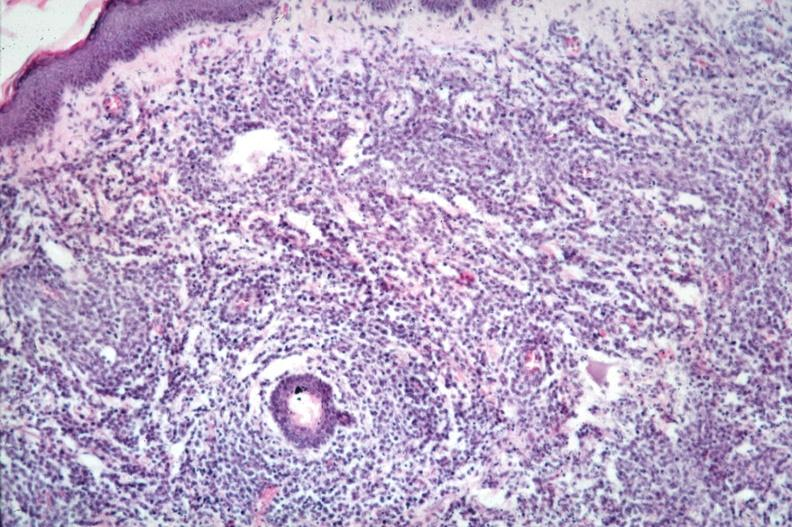what is present?
Answer the question using a single word or phrase. Lymphoblastic lymphoma 